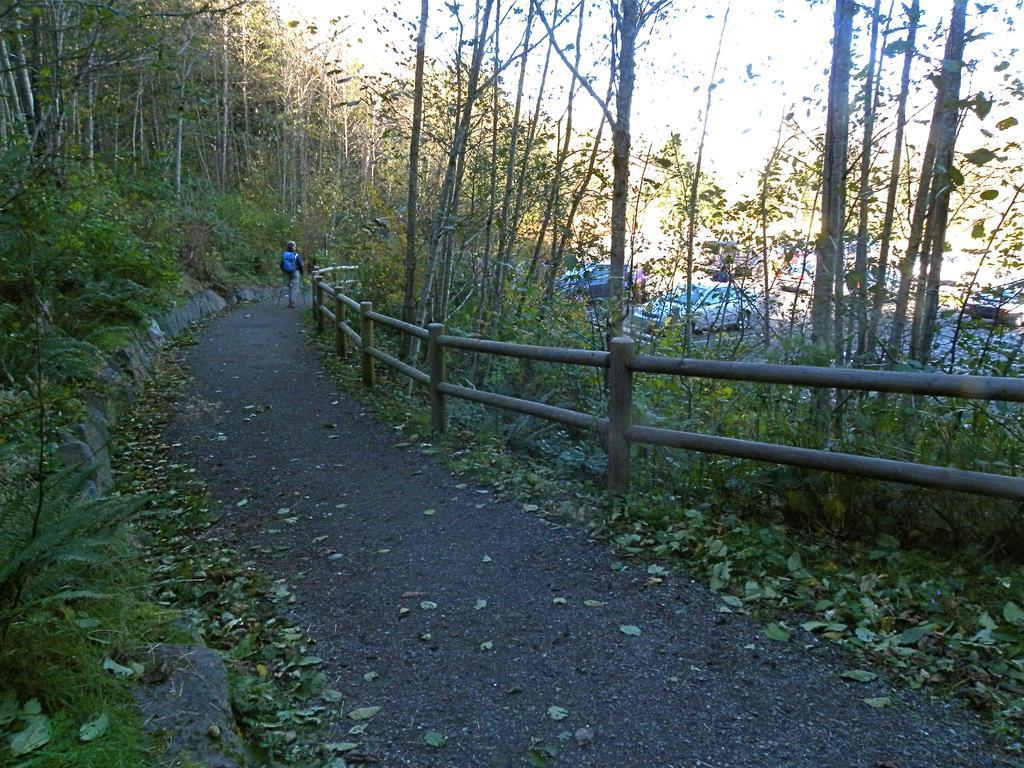In one or two sentences, can you explain what this image depicts? In the image we can see there is a person standing on the road and there are trees on both the sides. There are cars parked on the road. 